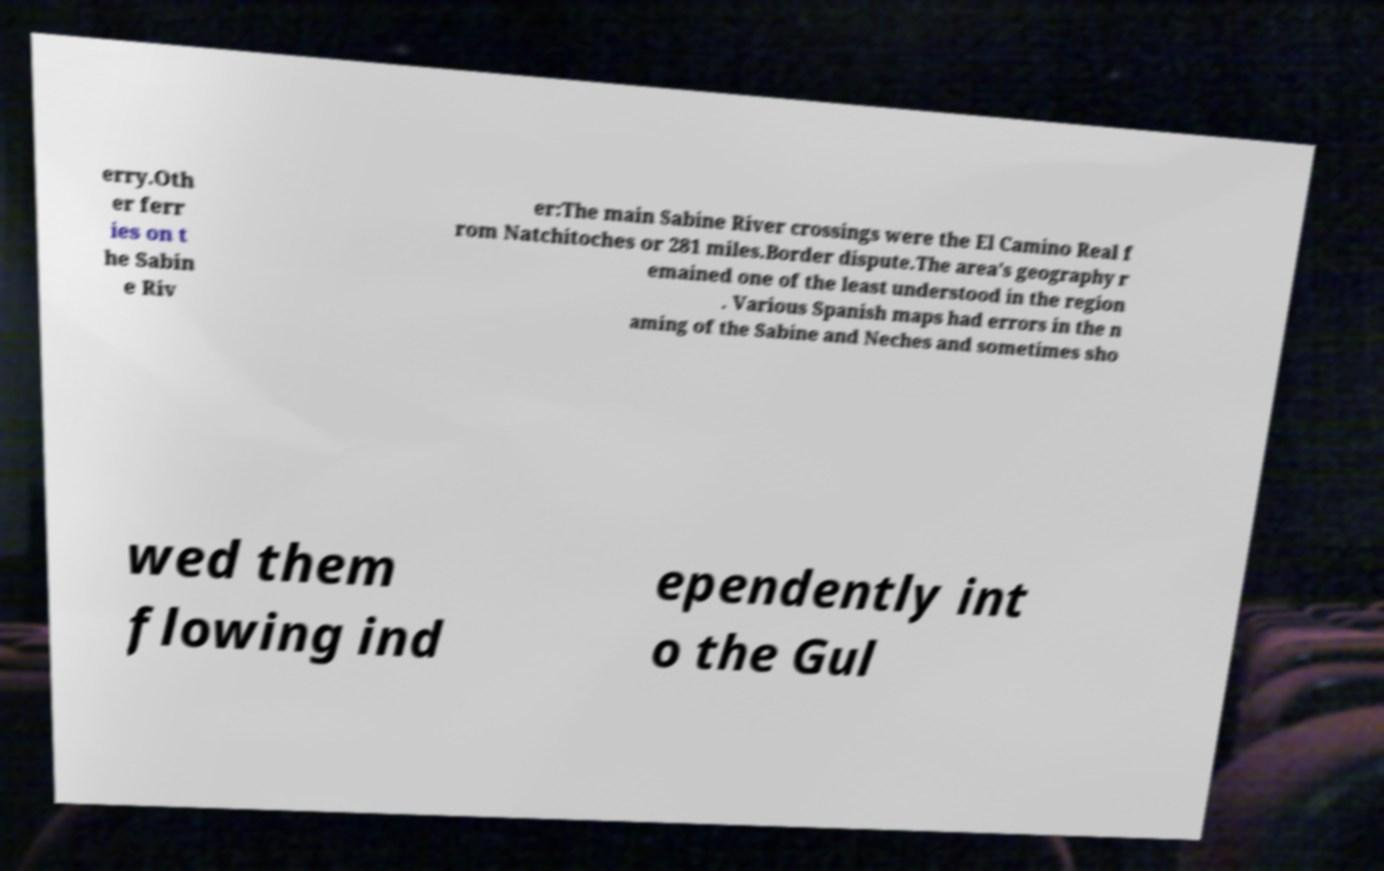What messages or text are displayed in this image? I need them in a readable, typed format. erry.Oth er ferr ies on t he Sabin e Riv er:The main Sabine River crossings were the El Camino Real f rom Natchitoches or 281 miles.Border dispute.The area's geography r emained one of the least understood in the region . Various Spanish maps had errors in the n aming of the Sabine and Neches and sometimes sho wed them flowing ind ependently int o the Gul 